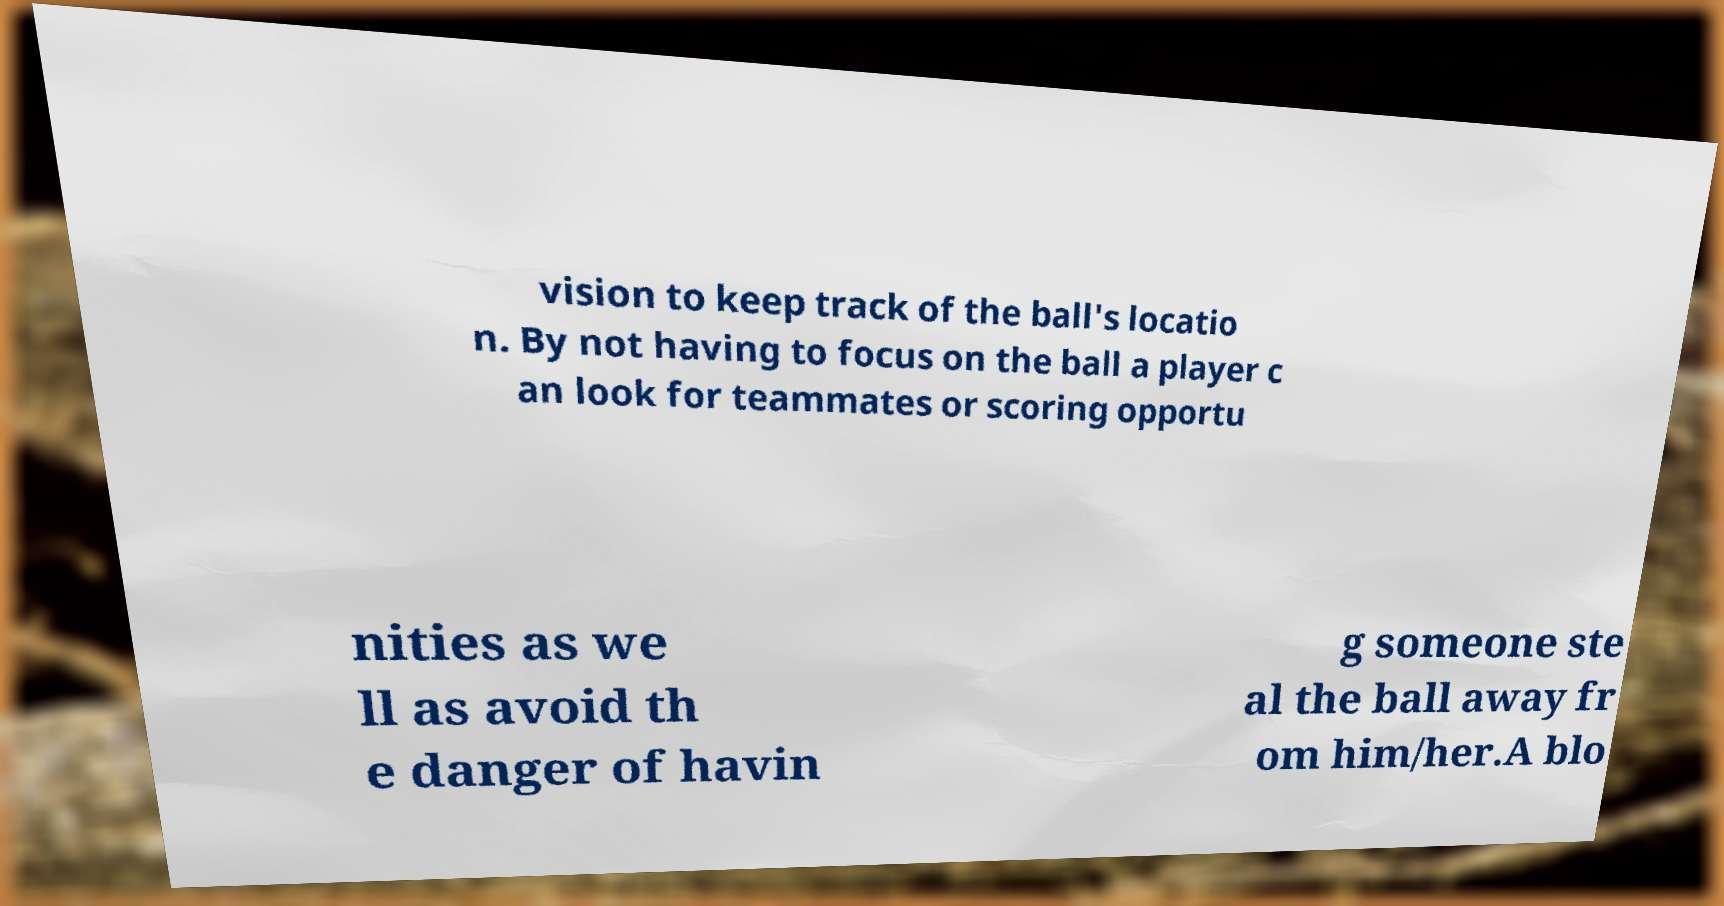Can you read and provide the text displayed in the image?This photo seems to have some interesting text. Can you extract and type it out for me? vision to keep track of the ball's locatio n. By not having to focus on the ball a player c an look for teammates or scoring opportu nities as we ll as avoid th e danger of havin g someone ste al the ball away fr om him/her.A blo 